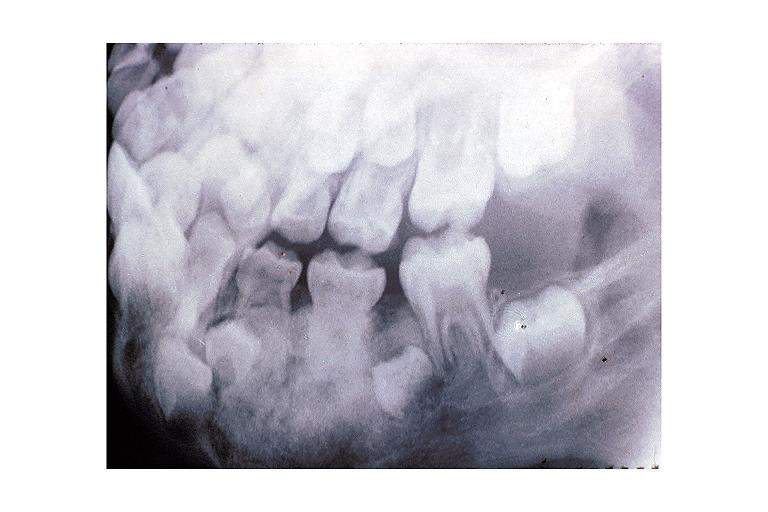what is present?
Answer the question using a single word or phrase. Oral 